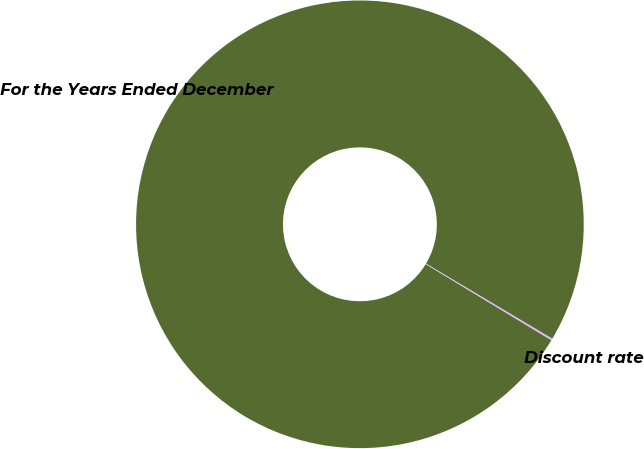<chart> <loc_0><loc_0><loc_500><loc_500><pie_chart><fcel>For the Years Ended December<fcel>Discount rate<nl><fcel>99.88%<fcel>0.12%<nl></chart> 